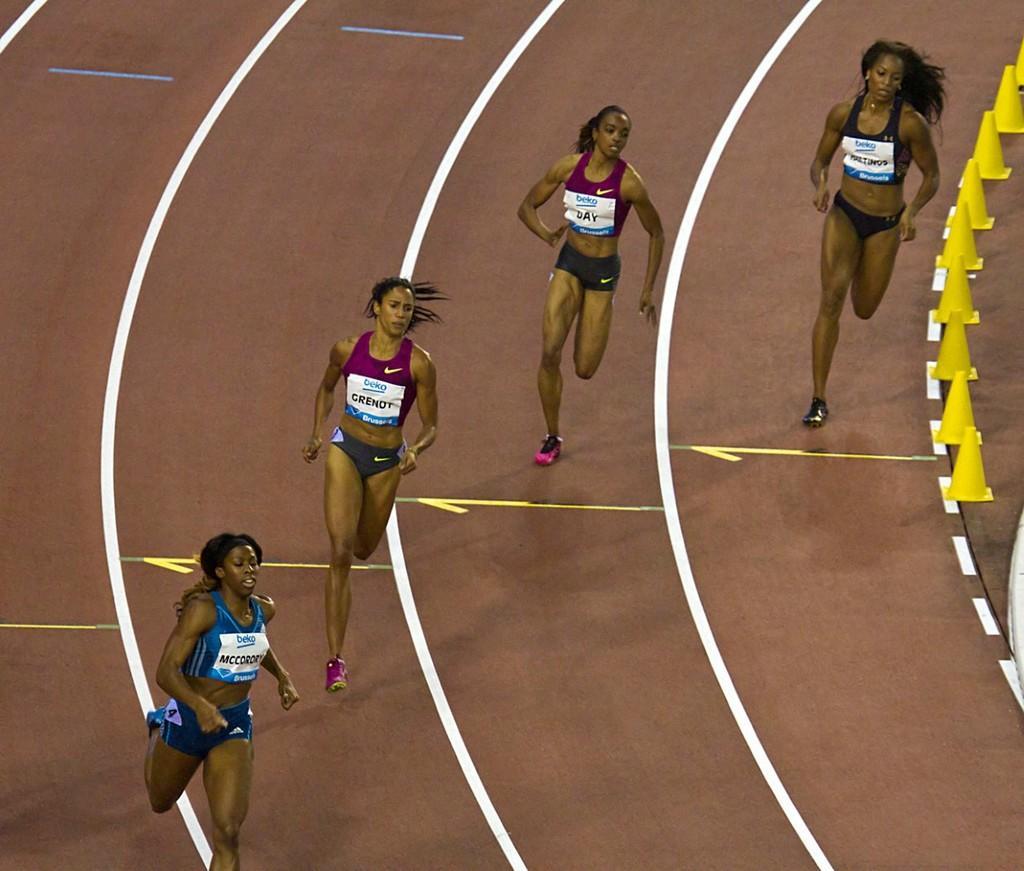In one or two sentences, can you explain what this image depicts? In this picture there are women running on a running track. 